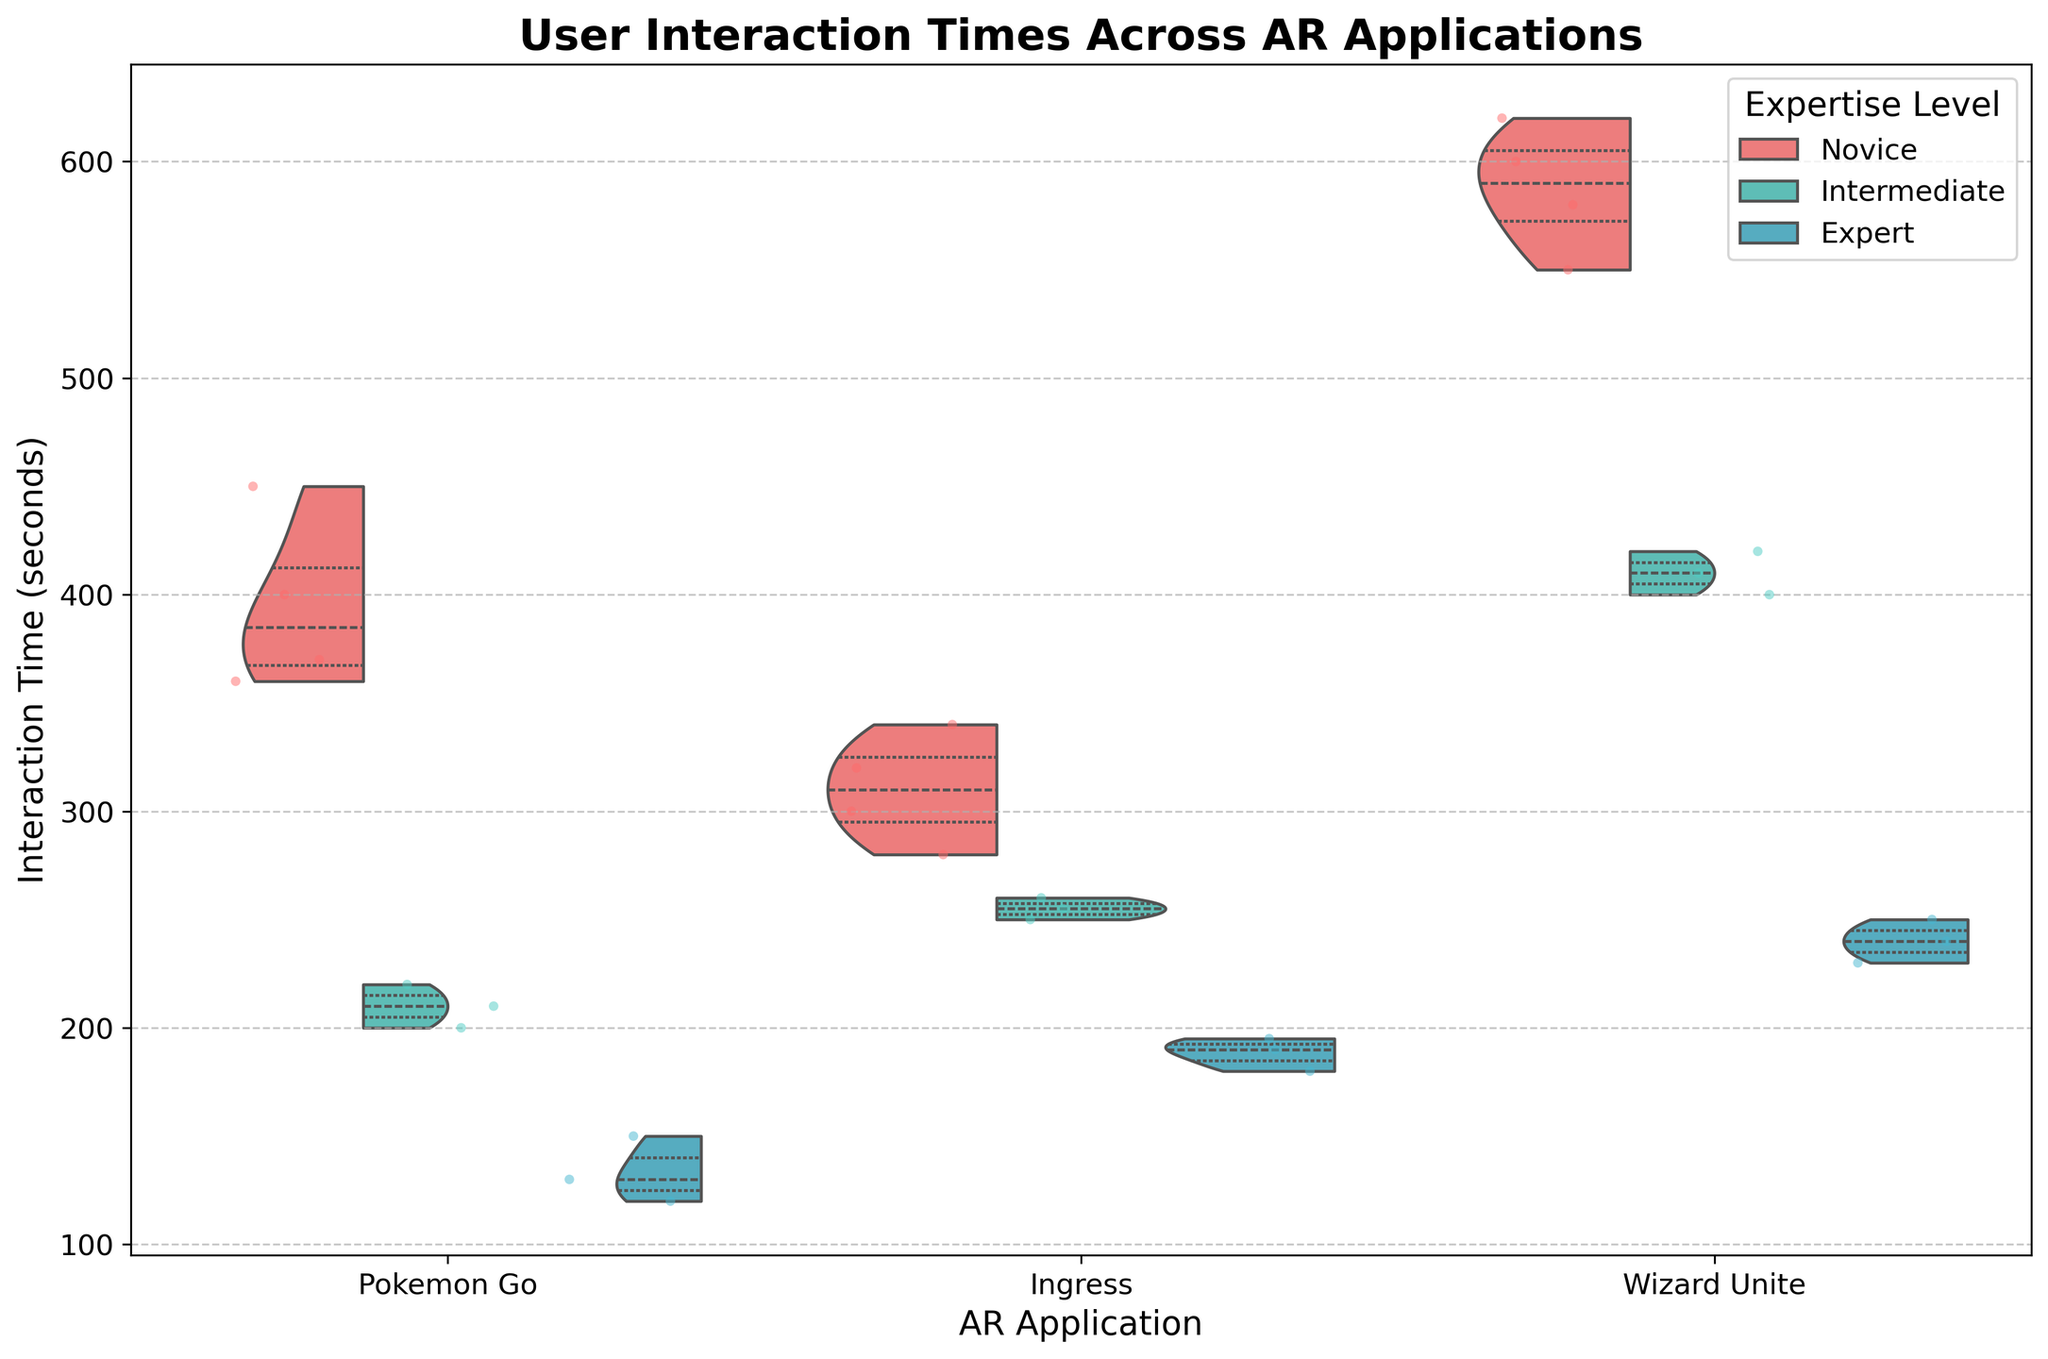Which application has the widest range of interaction times for novice users? To determine the application with the widest range of interaction times for novice users, observe the spread of jittered points and the width of the violin plot for each AR application under the 'Novice' expertise level. 'Wizard Unite' shows the widest spread indicating the highest range of interaction times.
Answer: Wizard Unite In which application do expert users spend the least time interacting? By looking at the lower quartile and outliers in the violin plot for each application under the 'Expert' expertise level, 'Pokemon Go' has the least interaction times among expert users.
Answer: Pokemon Go What is the shape of the distribution for intermediate users in 'Ingress'? Examine the violin plot for 'Ingress' under the 'Intermediate' expertise level. It shows a relatively narrow and symmetrical distribution, indicating less variability and concentration around the median.
Answer: Symmetrical and narrow How do the median interaction times for 'Wizard Unite' compare across the three expertise levels? Observe the location of the white dot or the center line within the violin plot for 'Wizard Unite' across all expertise levels. The median interaction time is highest for novice users, followed by intermediate users, and is lowest for expert users.
Answer: Novices > Intermediate > Experts Which group exhibits the most variability in interaction times? To determine the group with the highest variability, look for the widest violin plot with the most dispersed jittered points. 'Novice' users in 'Wizard Unite' exhibit the widest spread and the most dispersed points, indicating the highest variability.
Answer: Novices in Wizard Unite Are there any significant outliers in intermediate users' interaction times for 'Pokemon Go'? Inspect the jittered points and the shape of the violin plot for 'Pokemon Go' under the 'Intermediate' expertise level. There are no significant outliers, as all points are close to the main body of the distribution.
Answer: No significant outliers Compare the interaction times of novice and expert users in 'Ingress'. Which group has higher interaction times on average? Review the central tendency and the spread of the violin plots for 'Ingress' under 'Novice' and 'Expert' expertise levels. Novice users have a higher average interaction time, as the central line and majority of the jitter points are higher compared to expert users.
Answer: Novice users For each expertise level, which application has the lowest median interaction time? Evaluate the position of the white dots (representing the median) in each violin plot for all applications and expertise levels. For Novices, it's 'Ingress', for Intermediate, it's 'Pokemon Go', and for Experts, it's also 'Pokemon Go'.
Answer: Ingress (Novices), Pokemon Go (Intermediate), Pokemon Go (Experts) Identify the AR application with the most consistent interaction times for all levels of expertise. Identify the application with the narrowest and most uniform violin plots across all expertise levels, which suggests consistency in interaction times. 'Ingress' appears to have the most consistent interaction times across novices, intermediates, and experts.
Answer: Ingress 